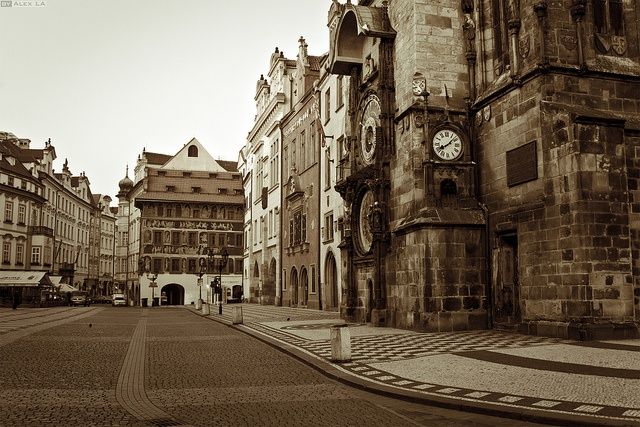Describe the objects in this image and their specific colors. I can see clock in beige, maroon, black, and gray tones, clock in beige, tan, and gray tones, car in beige, black, and gray tones, clock in beige, tan, and gray tones, and car in beige, black, maroon, and tan tones in this image. 